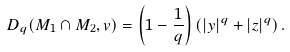<formula> <loc_0><loc_0><loc_500><loc_500>D _ { q } ( M _ { 1 } \cap M _ { 2 } , v ) = \left ( 1 - \frac { 1 } { q } \right ) \left ( | y | ^ { q } + | z | ^ { q } \right ) .</formula> 